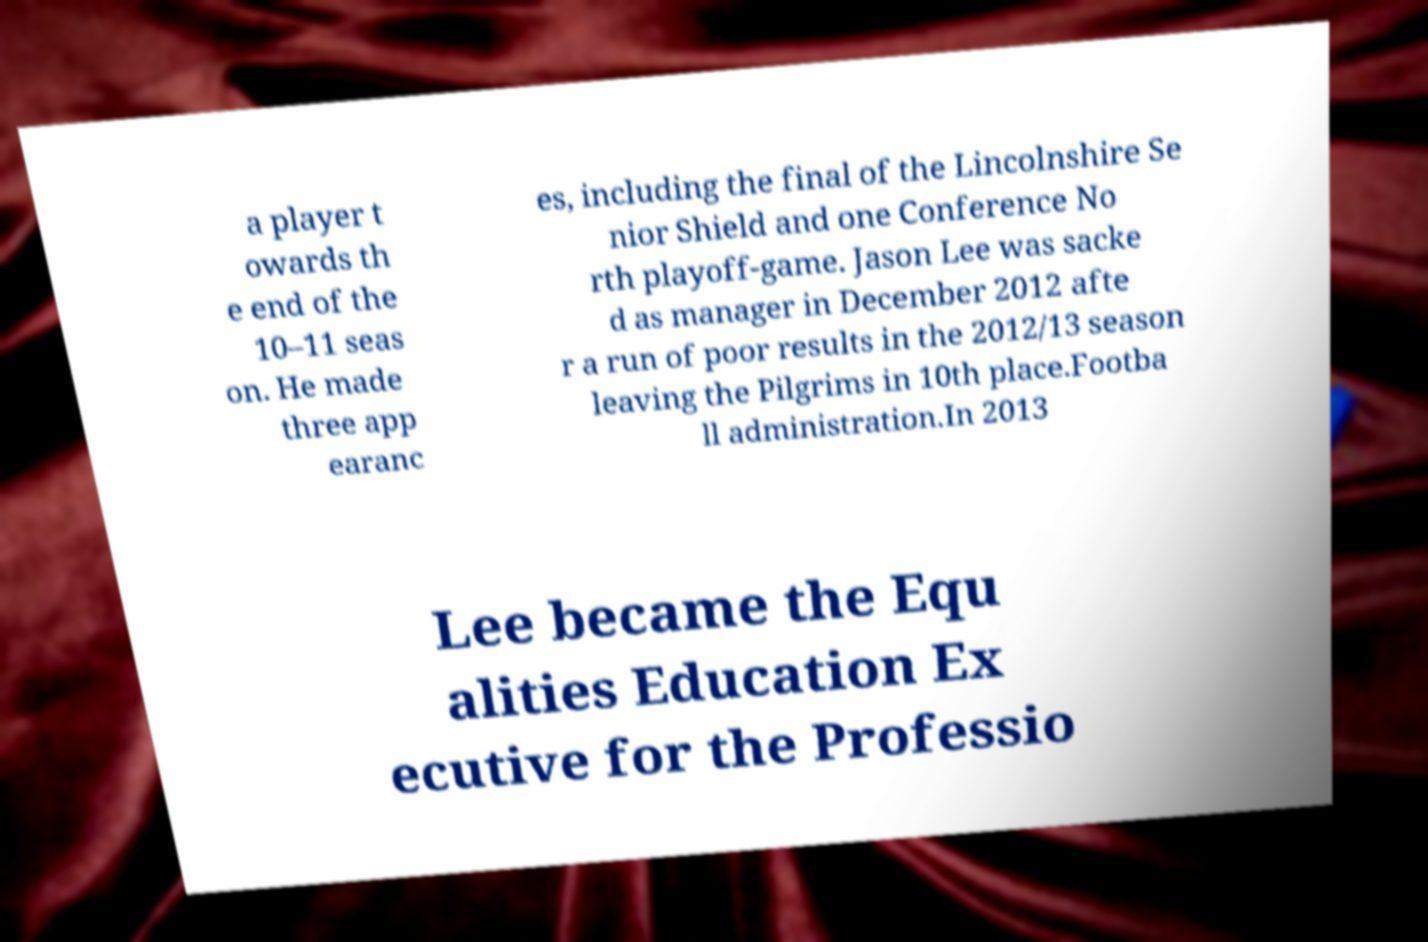Can you accurately transcribe the text from the provided image for me? a player t owards th e end of the 10–11 seas on. He made three app earanc es, including the final of the Lincolnshire Se nior Shield and one Conference No rth playoff-game. Jason Lee was sacke d as manager in December 2012 afte r a run of poor results in the 2012/13 season leaving the Pilgrims in 10th place.Footba ll administration.In 2013 Lee became the Equ alities Education Ex ecutive for the Professio 